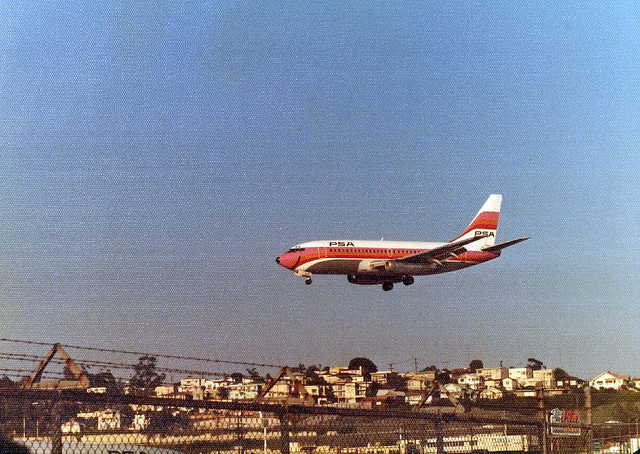How many pillows in the chair on the right? The original question seems to be based on a misunderstanding of the image content. There is no chair visible in the photograph; rather, it features an airplane flying above a landscape with houses. Therefore, no accurate count of pillows can be provided for a non-existent chair. 